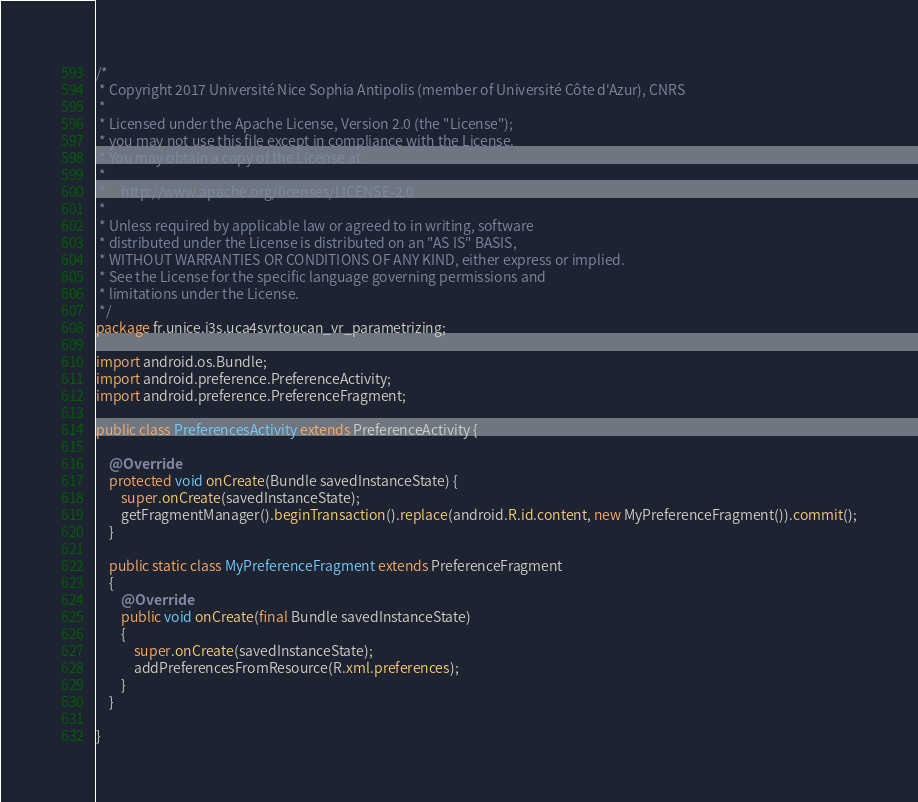Convert code to text. <code><loc_0><loc_0><loc_500><loc_500><_Java_>/*
 * Copyright 2017 Université Nice Sophia Antipolis (member of Université Côte d'Azur), CNRS
 *
 * Licensed under the Apache License, Version 2.0 (the "License");
 * you may not use this file except in compliance with the License.
 * You may obtain a copy of the License at
 *
 *     http://www.apache.org/licenses/LICENSE-2.0
 *
 * Unless required by applicable law or agreed to in writing, software
 * distributed under the License is distributed on an "AS IS" BASIS,
 * WITHOUT WARRANTIES OR CONDITIONS OF ANY KIND, either express or implied.
 * See the License for the specific language governing permissions and
 * limitations under the License.
 */
package fr.unice.i3s.uca4svr.toucan_vr_parametrizing;

import android.os.Bundle;
import android.preference.PreferenceActivity;
import android.preference.PreferenceFragment;

public class PreferencesActivity extends PreferenceActivity {

    @Override
    protected void onCreate(Bundle savedInstanceState) {
        super.onCreate(savedInstanceState);
        getFragmentManager().beginTransaction().replace(android.R.id.content, new MyPreferenceFragment()).commit();
    }

    public static class MyPreferenceFragment extends PreferenceFragment
    {
        @Override
        public void onCreate(final Bundle savedInstanceState)
        {
            super.onCreate(savedInstanceState);
            addPreferencesFromResource(R.xml.preferences);
        }
    }

}
</code> 